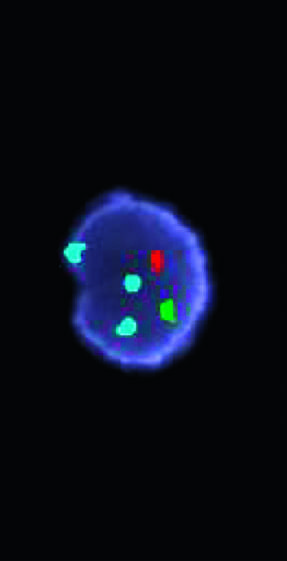have three different fluorescent probes been used in a fish cocktail?
Answer the question using a single word or phrase. Yes 